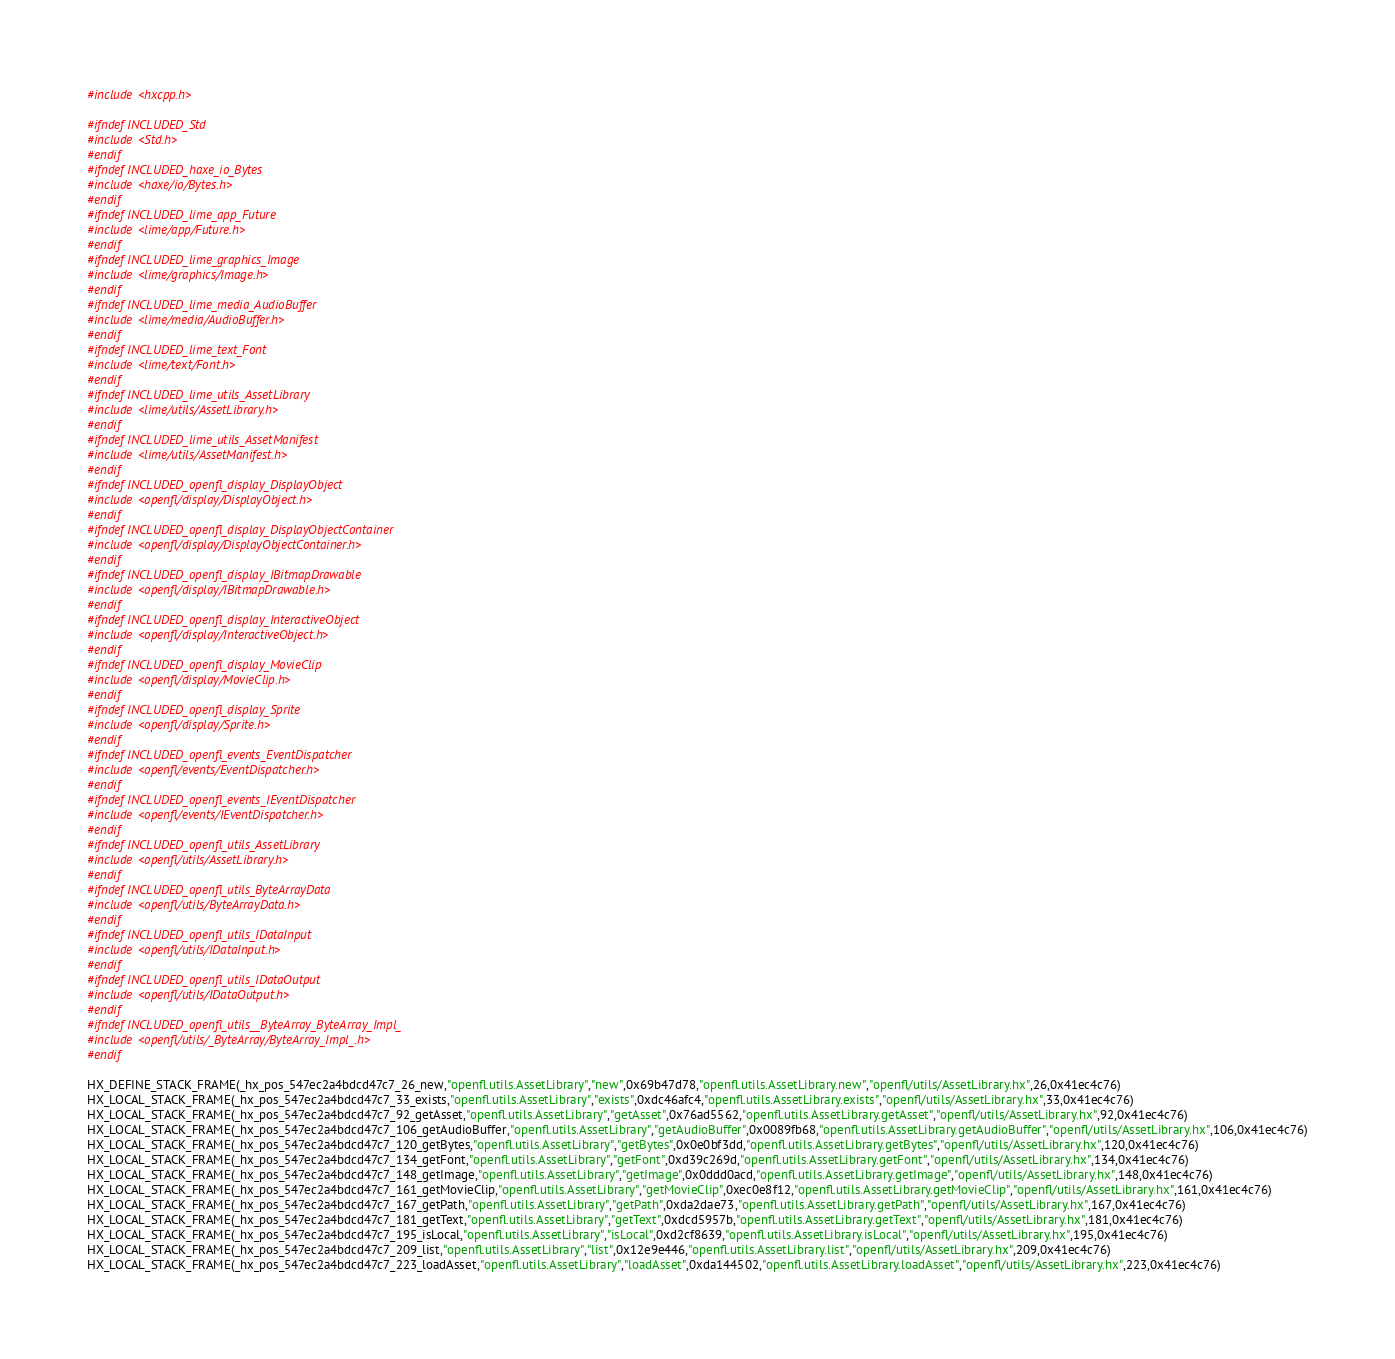<code> <loc_0><loc_0><loc_500><loc_500><_C++_>#include <hxcpp.h>

#ifndef INCLUDED_Std
#include <Std.h>
#endif
#ifndef INCLUDED_haxe_io_Bytes
#include <haxe/io/Bytes.h>
#endif
#ifndef INCLUDED_lime_app_Future
#include <lime/app/Future.h>
#endif
#ifndef INCLUDED_lime_graphics_Image
#include <lime/graphics/Image.h>
#endif
#ifndef INCLUDED_lime_media_AudioBuffer
#include <lime/media/AudioBuffer.h>
#endif
#ifndef INCLUDED_lime_text_Font
#include <lime/text/Font.h>
#endif
#ifndef INCLUDED_lime_utils_AssetLibrary
#include <lime/utils/AssetLibrary.h>
#endif
#ifndef INCLUDED_lime_utils_AssetManifest
#include <lime/utils/AssetManifest.h>
#endif
#ifndef INCLUDED_openfl_display_DisplayObject
#include <openfl/display/DisplayObject.h>
#endif
#ifndef INCLUDED_openfl_display_DisplayObjectContainer
#include <openfl/display/DisplayObjectContainer.h>
#endif
#ifndef INCLUDED_openfl_display_IBitmapDrawable
#include <openfl/display/IBitmapDrawable.h>
#endif
#ifndef INCLUDED_openfl_display_InteractiveObject
#include <openfl/display/InteractiveObject.h>
#endif
#ifndef INCLUDED_openfl_display_MovieClip
#include <openfl/display/MovieClip.h>
#endif
#ifndef INCLUDED_openfl_display_Sprite
#include <openfl/display/Sprite.h>
#endif
#ifndef INCLUDED_openfl_events_EventDispatcher
#include <openfl/events/EventDispatcher.h>
#endif
#ifndef INCLUDED_openfl_events_IEventDispatcher
#include <openfl/events/IEventDispatcher.h>
#endif
#ifndef INCLUDED_openfl_utils_AssetLibrary
#include <openfl/utils/AssetLibrary.h>
#endif
#ifndef INCLUDED_openfl_utils_ByteArrayData
#include <openfl/utils/ByteArrayData.h>
#endif
#ifndef INCLUDED_openfl_utils_IDataInput
#include <openfl/utils/IDataInput.h>
#endif
#ifndef INCLUDED_openfl_utils_IDataOutput
#include <openfl/utils/IDataOutput.h>
#endif
#ifndef INCLUDED_openfl_utils__ByteArray_ByteArray_Impl_
#include <openfl/utils/_ByteArray/ByteArray_Impl_.h>
#endif

HX_DEFINE_STACK_FRAME(_hx_pos_547ec2a4bdcd47c7_26_new,"openfl.utils.AssetLibrary","new",0x69b47d78,"openfl.utils.AssetLibrary.new","openfl/utils/AssetLibrary.hx",26,0x41ec4c76)
HX_LOCAL_STACK_FRAME(_hx_pos_547ec2a4bdcd47c7_33_exists,"openfl.utils.AssetLibrary","exists",0xdc46afc4,"openfl.utils.AssetLibrary.exists","openfl/utils/AssetLibrary.hx",33,0x41ec4c76)
HX_LOCAL_STACK_FRAME(_hx_pos_547ec2a4bdcd47c7_92_getAsset,"openfl.utils.AssetLibrary","getAsset",0x76ad5562,"openfl.utils.AssetLibrary.getAsset","openfl/utils/AssetLibrary.hx",92,0x41ec4c76)
HX_LOCAL_STACK_FRAME(_hx_pos_547ec2a4bdcd47c7_106_getAudioBuffer,"openfl.utils.AssetLibrary","getAudioBuffer",0x0089fb68,"openfl.utils.AssetLibrary.getAudioBuffer","openfl/utils/AssetLibrary.hx",106,0x41ec4c76)
HX_LOCAL_STACK_FRAME(_hx_pos_547ec2a4bdcd47c7_120_getBytes,"openfl.utils.AssetLibrary","getBytes",0x0e0bf3dd,"openfl.utils.AssetLibrary.getBytes","openfl/utils/AssetLibrary.hx",120,0x41ec4c76)
HX_LOCAL_STACK_FRAME(_hx_pos_547ec2a4bdcd47c7_134_getFont,"openfl.utils.AssetLibrary","getFont",0xd39c269d,"openfl.utils.AssetLibrary.getFont","openfl/utils/AssetLibrary.hx",134,0x41ec4c76)
HX_LOCAL_STACK_FRAME(_hx_pos_547ec2a4bdcd47c7_148_getImage,"openfl.utils.AssetLibrary","getImage",0x0ddd0acd,"openfl.utils.AssetLibrary.getImage","openfl/utils/AssetLibrary.hx",148,0x41ec4c76)
HX_LOCAL_STACK_FRAME(_hx_pos_547ec2a4bdcd47c7_161_getMovieClip,"openfl.utils.AssetLibrary","getMovieClip",0xec0e8f12,"openfl.utils.AssetLibrary.getMovieClip","openfl/utils/AssetLibrary.hx",161,0x41ec4c76)
HX_LOCAL_STACK_FRAME(_hx_pos_547ec2a4bdcd47c7_167_getPath,"openfl.utils.AssetLibrary","getPath",0xda2dae73,"openfl.utils.AssetLibrary.getPath","openfl/utils/AssetLibrary.hx",167,0x41ec4c76)
HX_LOCAL_STACK_FRAME(_hx_pos_547ec2a4bdcd47c7_181_getText,"openfl.utils.AssetLibrary","getText",0xdcd5957b,"openfl.utils.AssetLibrary.getText","openfl/utils/AssetLibrary.hx",181,0x41ec4c76)
HX_LOCAL_STACK_FRAME(_hx_pos_547ec2a4bdcd47c7_195_isLocal,"openfl.utils.AssetLibrary","isLocal",0xd2cf8639,"openfl.utils.AssetLibrary.isLocal","openfl/utils/AssetLibrary.hx",195,0x41ec4c76)
HX_LOCAL_STACK_FRAME(_hx_pos_547ec2a4bdcd47c7_209_list,"openfl.utils.AssetLibrary","list",0x12e9e446,"openfl.utils.AssetLibrary.list","openfl/utils/AssetLibrary.hx",209,0x41ec4c76)
HX_LOCAL_STACK_FRAME(_hx_pos_547ec2a4bdcd47c7_223_loadAsset,"openfl.utils.AssetLibrary","loadAsset",0xda144502,"openfl.utils.AssetLibrary.loadAsset","openfl/utils/AssetLibrary.hx",223,0x41ec4c76)</code> 